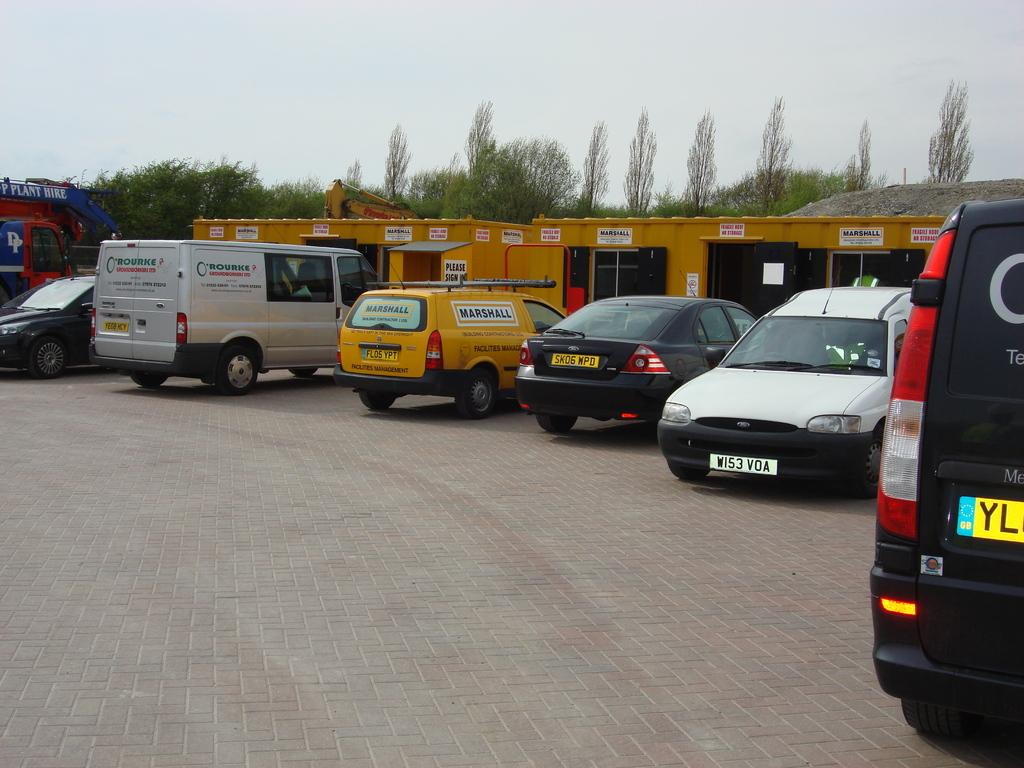<image>
Describe the image concisely. Some vehicles, with one in level having the word Marshall on it. 